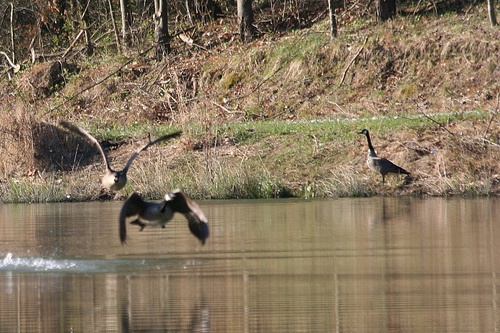Describe the objects in this image and their specific colors. I can see bird in black and gray tones, bird in black, gray, and lightgray tones, and bird in black, gray, darkgray, and tan tones in this image. 